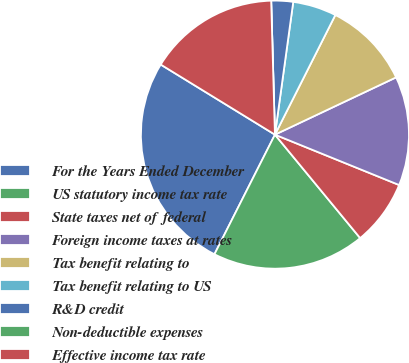<chart> <loc_0><loc_0><loc_500><loc_500><pie_chart><fcel>For the Years Ended December<fcel>US statutory income tax rate<fcel>State taxes net of federal<fcel>Foreign income taxes at rates<fcel>Tax benefit relating to<fcel>Tax benefit relating to US<fcel>R&D credit<fcel>Non-deductible expenses<fcel>Effective income tax rate<nl><fcel>26.31%<fcel>18.42%<fcel>7.9%<fcel>13.16%<fcel>10.53%<fcel>5.26%<fcel>2.63%<fcel>0.0%<fcel>15.79%<nl></chart> 